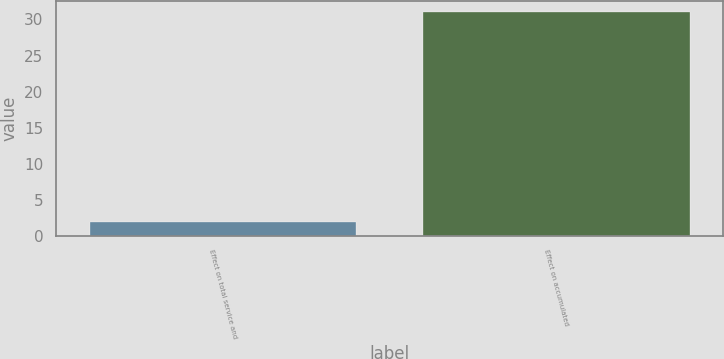Convert chart. <chart><loc_0><loc_0><loc_500><loc_500><bar_chart><fcel>Effect on total service and<fcel>Effect on accumulated<nl><fcel>2<fcel>31<nl></chart> 